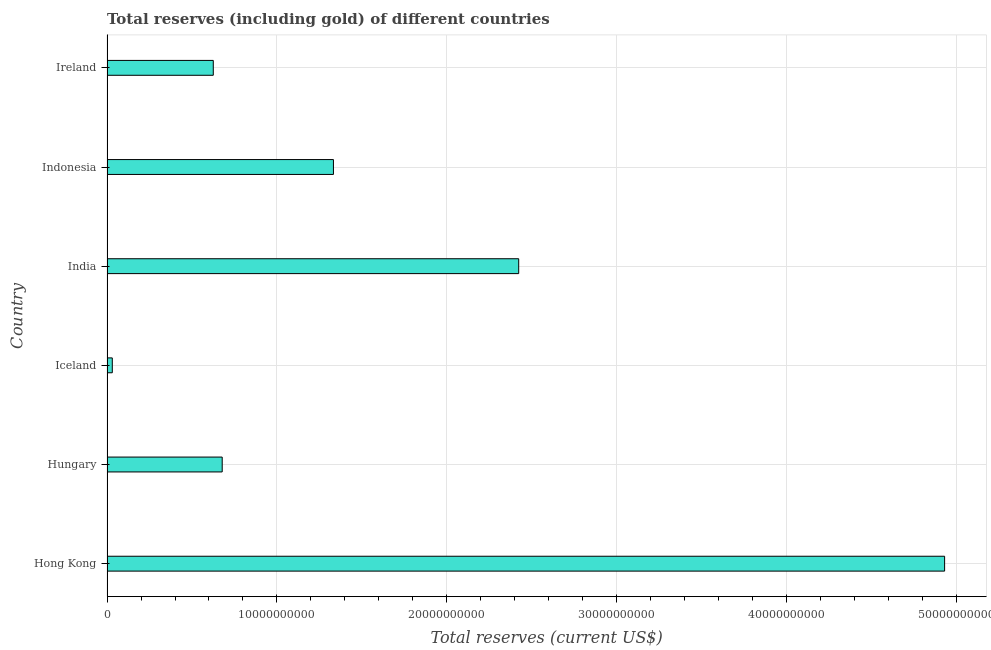What is the title of the graph?
Offer a very short reply. Total reserves (including gold) of different countries. What is the label or title of the X-axis?
Keep it short and to the point. Total reserves (current US$). What is the total reserves (including gold) in Indonesia?
Your answer should be very brief. 1.33e+1. Across all countries, what is the maximum total reserves (including gold)?
Offer a terse response. 4.93e+1. Across all countries, what is the minimum total reserves (including gold)?
Your answer should be very brief. 3.12e+08. In which country was the total reserves (including gold) maximum?
Provide a succinct answer. Hong Kong. What is the sum of the total reserves (including gold)?
Offer a very short reply. 1.00e+11. What is the difference between the total reserves (including gold) in Hong Kong and Hungary?
Your answer should be compact. 4.25e+1. What is the average total reserves (including gold) per country?
Your response must be concise. 1.67e+1. What is the median total reserves (including gold)?
Your response must be concise. 1.00e+1. What is the ratio of the total reserves (including gold) in Iceland to that in India?
Give a very brief answer. 0.01. Is the total reserves (including gold) in Hong Kong less than that in Iceland?
Your answer should be compact. No. What is the difference between the highest and the second highest total reserves (including gold)?
Provide a succinct answer. 2.51e+1. Is the sum of the total reserves (including gold) in Hong Kong and Ireland greater than the maximum total reserves (including gold) across all countries?
Offer a terse response. Yes. What is the difference between the highest and the lowest total reserves (including gold)?
Your answer should be very brief. 4.90e+1. How many countries are there in the graph?
Keep it short and to the point. 6. What is the difference between two consecutive major ticks on the X-axis?
Your answer should be compact. 1.00e+1. Are the values on the major ticks of X-axis written in scientific E-notation?
Ensure brevity in your answer.  No. What is the Total reserves (current US$) of Hong Kong?
Keep it short and to the point. 4.93e+1. What is the Total reserves (current US$) of Hungary?
Ensure brevity in your answer.  6.78e+09. What is the Total reserves (current US$) in Iceland?
Offer a very short reply. 3.12e+08. What is the Total reserves (current US$) in India?
Provide a short and direct response. 2.42e+1. What is the Total reserves (current US$) in Indonesia?
Offer a terse response. 1.33e+1. What is the Total reserves (current US$) in Ireland?
Keep it short and to the point. 6.25e+09. What is the difference between the Total reserves (current US$) in Hong Kong and Hungary?
Provide a succinct answer. 4.25e+1. What is the difference between the Total reserves (current US$) in Hong Kong and Iceland?
Provide a succinct answer. 4.90e+1. What is the difference between the Total reserves (current US$) in Hong Kong and India?
Keep it short and to the point. 2.51e+1. What is the difference between the Total reserves (current US$) in Hong Kong and Indonesia?
Offer a terse response. 3.60e+1. What is the difference between the Total reserves (current US$) in Hong Kong and Ireland?
Provide a short and direct response. 4.30e+1. What is the difference between the Total reserves (current US$) in Hungary and Iceland?
Give a very brief answer. 6.47e+09. What is the difference between the Total reserves (current US$) in Hungary and India?
Provide a short and direct response. -1.74e+1. What is the difference between the Total reserves (current US$) in Hungary and Indonesia?
Your answer should be very brief. -6.54e+09. What is the difference between the Total reserves (current US$) in Hungary and Ireland?
Offer a very short reply. 5.25e+08. What is the difference between the Total reserves (current US$) in Iceland and India?
Ensure brevity in your answer.  -2.39e+1. What is the difference between the Total reserves (current US$) in Iceland and Indonesia?
Your answer should be compact. -1.30e+1. What is the difference between the Total reserves (current US$) in Iceland and Ireland?
Provide a short and direct response. -5.94e+09. What is the difference between the Total reserves (current US$) in India and Indonesia?
Give a very brief answer. 1.09e+1. What is the difference between the Total reserves (current US$) in India and Ireland?
Your answer should be compact. 1.80e+1. What is the difference between the Total reserves (current US$) in Indonesia and Ireland?
Your answer should be compact. 7.07e+09. What is the ratio of the Total reserves (current US$) in Hong Kong to that in Hungary?
Give a very brief answer. 7.27. What is the ratio of the Total reserves (current US$) in Hong Kong to that in Iceland?
Make the answer very short. 158.09. What is the ratio of the Total reserves (current US$) in Hong Kong to that in India?
Give a very brief answer. 2.03. What is the ratio of the Total reserves (current US$) in Hong Kong to that in Indonesia?
Ensure brevity in your answer.  3.7. What is the ratio of the Total reserves (current US$) in Hong Kong to that in Ireland?
Keep it short and to the point. 7.88. What is the ratio of the Total reserves (current US$) in Hungary to that in Iceland?
Make the answer very short. 21.75. What is the ratio of the Total reserves (current US$) in Hungary to that in India?
Your answer should be very brief. 0.28. What is the ratio of the Total reserves (current US$) in Hungary to that in Indonesia?
Provide a succinct answer. 0.51. What is the ratio of the Total reserves (current US$) in Hungary to that in Ireland?
Provide a succinct answer. 1.08. What is the ratio of the Total reserves (current US$) in Iceland to that in India?
Offer a terse response. 0.01. What is the ratio of the Total reserves (current US$) in Iceland to that in Indonesia?
Provide a short and direct response. 0.02. What is the ratio of the Total reserves (current US$) in Iceland to that in Ireland?
Offer a terse response. 0.05. What is the ratio of the Total reserves (current US$) in India to that in Indonesia?
Make the answer very short. 1.82. What is the ratio of the Total reserves (current US$) in India to that in Ireland?
Make the answer very short. 3.87. What is the ratio of the Total reserves (current US$) in Indonesia to that in Ireland?
Your response must be concise. 2.13. 